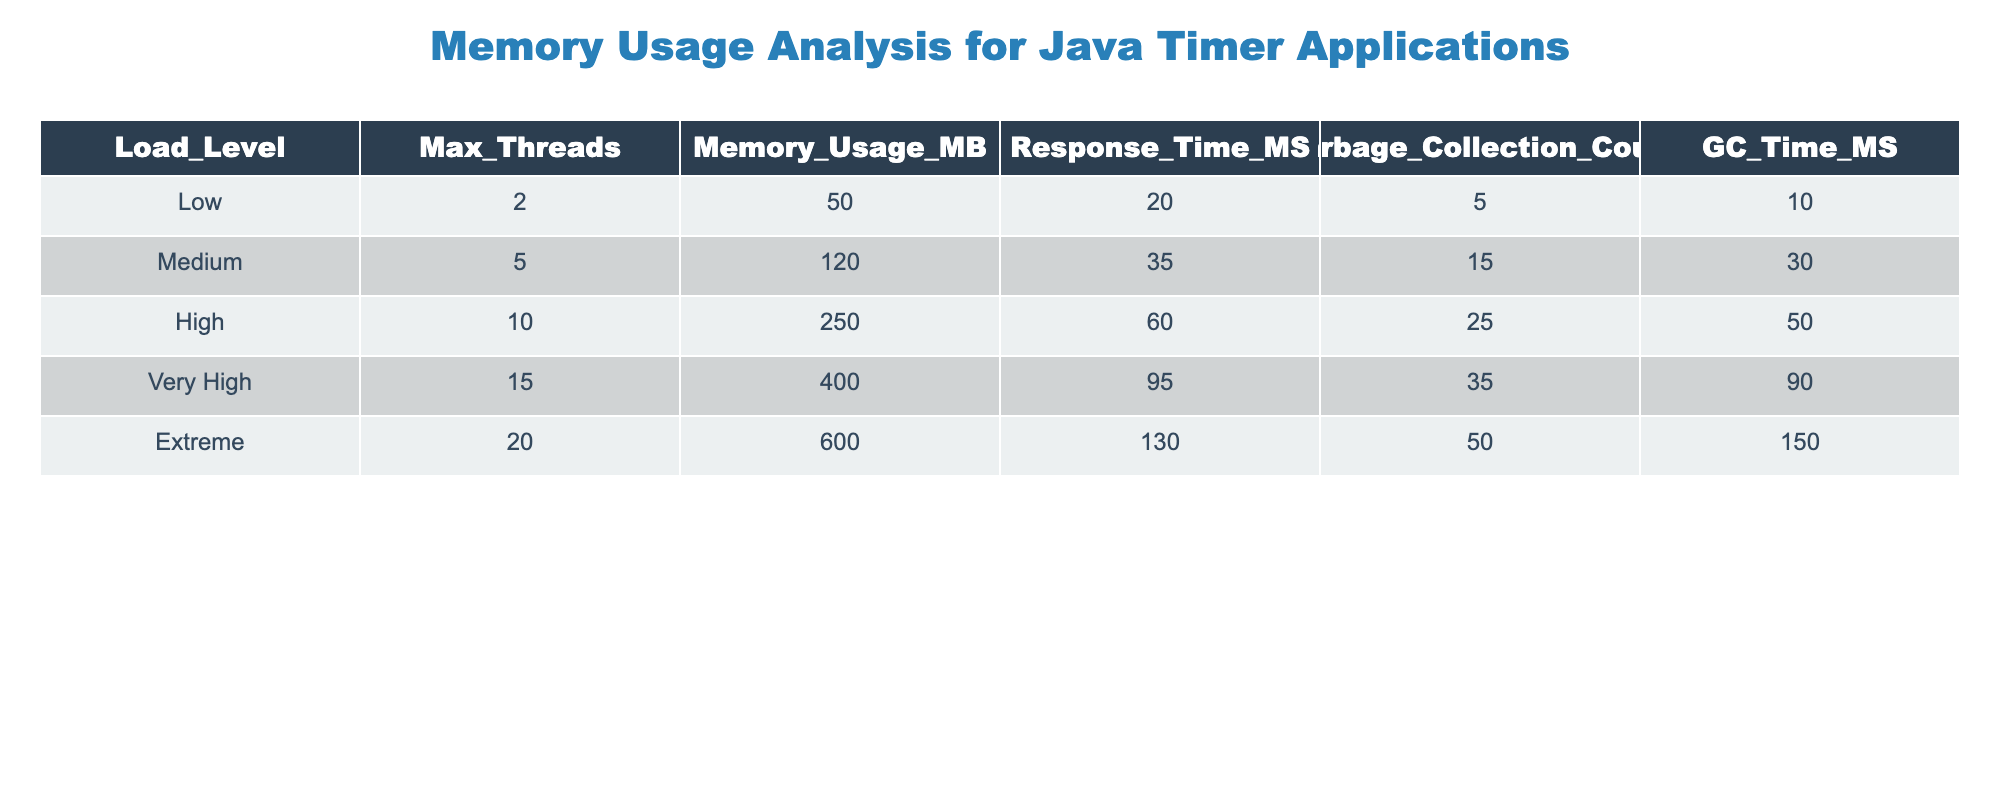What is the maximum memory usage recorded at the highest load level? The highest load level is labeled as "Extreme". Referring to that row, the maximum memory usage recorded is 600 MB.
Answer: 600 MB What is the response time when the load level is set to Medium? From the table, when the load level is "Medium", the response time is given as 35 milliseconds.
Answer: 35 milliseconds How many times does garbage collection occur at the Very High load? According to the "Very High" load row, the garbage collection count is 35 times.
Answer: 35 times Is the memory usage at High load greater than the memory usage at Medium load? "High" load memory usage is 250 MB and "Medium" load usage is 120 MB. Since 250 > 120, the statement is true.
Answer: Yes What is the average memory usage across all load levels? To find the average memory usage, sum all memory usages (50 + 120 + 250 + 400 + 600 = 1420) and divide by the number of load levels (5). Thus, 1420 / 5 = 284.
Answer: 284 MB What is the difference in response time between Extreme load and Low load? The response time for "Extreme" load is 130 ms, and for "Low" load, it is 20 ms. The difference is calculated as 130 - 20 = 110 ms.
Answer: 110 ms At which load level does the garbage collection time exceed 100 ms? Looking through the table, the only load level where garbage collection time is greater than 100 ms is at the "Extreme" load, which has 150 ms.
Answer: Extreme What is the total garbage collection time across all load levels? To find the total garbage collection time, sum all GC times: 10 + 30 + 50 + 90 + 150 = 330 ms.
Answer: 330 ms Under High load, how many more threads are there compared to Low load? The "High" load has 10 threads, while the "Low" load has 2 threads. The difference is 10 - 2 = 8 threads.
Answer: 8 threads 